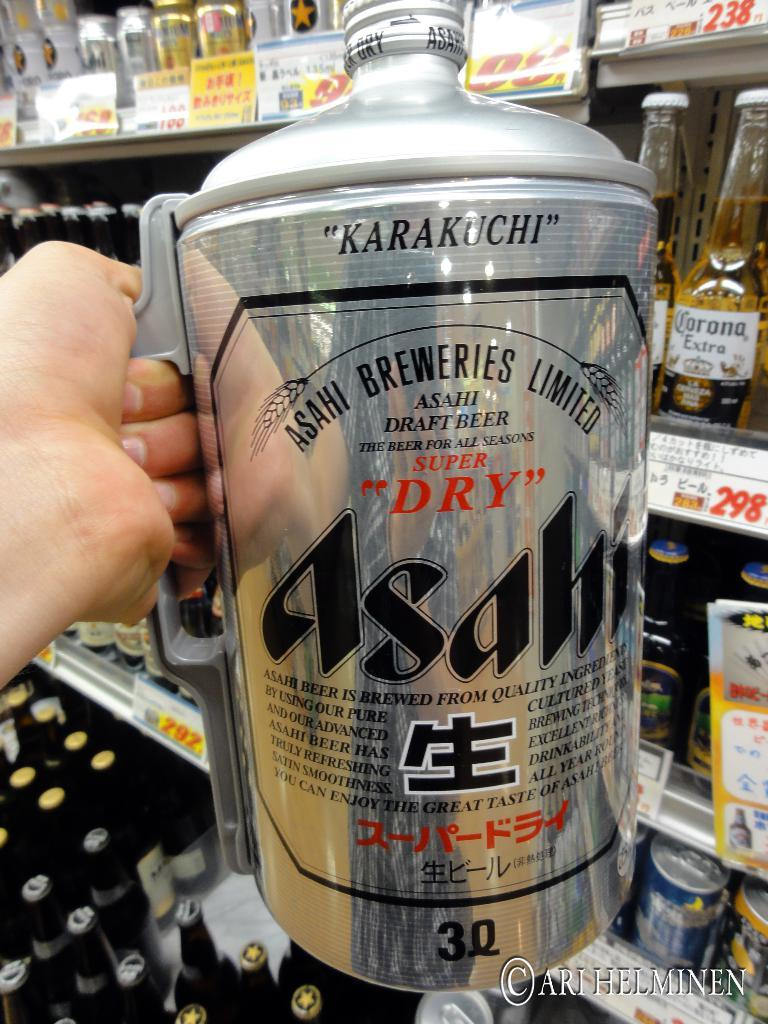<image>
Relay a brief, clear account of the picture shown. Person holding a giant jug with the words Asahi on it. 